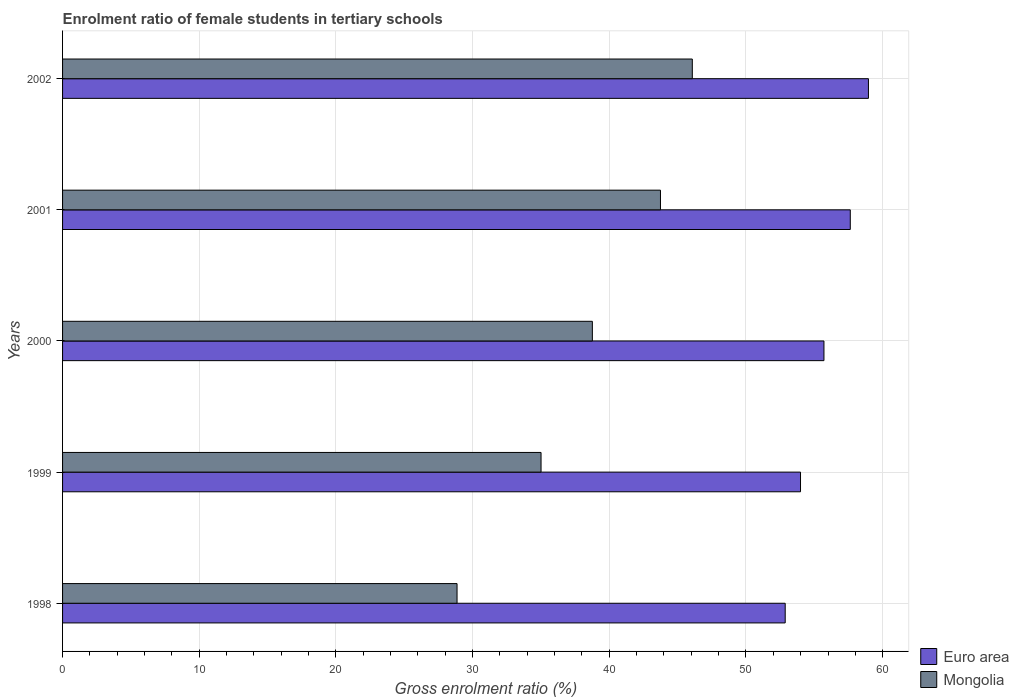In how many cases, is the number of bars for a given year not equal to the number of legend labels?
Provide a succinct answer. 0. What is the enrolment ratio of female students in tertiary schools in Mongolia in 2002?
Give a very brief answer. 46.07. Across all years, what is the maximum enrolment ratio of female students in tertiary schools in Mongolia?
Make the answer very short. 46.07. Across all years, what is the minimum enrolment ratio of female students in tertiary schools in Mongolia?
Keep it short and to the point. 28.86. In which year was the enrolment ratio of female students in tertiary schools in Mongolia minimum?
Keep it short and to the point. 1998. What is the total enrolment ratio of female students in tertiary schools in Euro area in the graph?
Ensure brevity in your answer.  279.15. What is the difference between the enrolment ratio of female students in tertiary schools in Euro area in 1998 and that in 1999?
Offer a terse response. -1.12. What is the difference between the enrolment ratio of female students in tertiary schools in Mongolia in 2001 and the enrolment ratio of female students in tertiary schools in Euro area in 1999?
Make the answer very short. -10.25. What is the average enrolment ratio of female students in tertiary schools in Mongolia per year?
Provide a succinct answer. 38.49. In the year 1999, what is the difference between the enrolment ratio of female students in tertiary schools in Euro area and enrolment ratio of female students in tertiary schools in Mongolia?
Make the answer very short. 18.98. In how many years, is the enrolment ratio of female students in tertiary schools in Euro area greater than 12 %?
Your answer should be compact. 5. What is the ratio of the enrolment ratio of female students in tertiary schools in Mongolia in 1998 to that in 2000?
Offer a terse response. 0.74. Is the enrolment ratio of female students in tertiary schools in Mongolia in 2000 less than that in 2001?
Your answer should be very brief. Yes. What is the difference between the highest and the second highest enrolment ratio of female students in tertiary schools in Mongolia?
Offer a terse response. 2.33. What is the difference between the highest and the lowest enrolment ratio of female students in tertiary schools in Mongolia?
Provide a succinct answer. 17.21. In how many years, is the enrolment ratio of female students in tertiary schools in Euro area greater than the average enrolment ratio of female students in tertiary schools in Euro area taken over all years?
Your answer should be very brief. 2. Is the sum of the enrolment ratio of female students in tertiary schools in Mongolia in 1999 and 2001 greater than the maximum enrolment ratio of female students in tertiary schools in Euro area across all years?
Your answer should be very brief. Yes. What does the 1st bar from the top in 2002 represents?
Your answer should be very brief. Mongolia. What does the 2nd bar from the bottom in 2000 represents?
Your answer should be very brief. Mongolia. How many bars are there?
Offer a very short reply. 10. Are the values on the major ticks of X-axis written in scientific E-notation?
Provide a succinct answer. No. Does the graph contain any zero values?
Your answer should be compact. No. Where does the legend appear in the graph?
Your response must be concise. Bottom right. How many legend labels are there?
Your answer should be very brief. 2. What is the title of the graph?
Your answer should be compact. Enrolment ratio of female students in tertiary schools. What is the Gross enrolment ratio (%) in Euro area in 1998?
Provide a short and direct response. 52.87. What is the Gross enrolment ratio (%) in Mongolia in 1998?
Keep it short and to the point. 28.86. What is the Gross enrolment ratio (%) of Euro area in 1999?
Your answer should be very brief. 53.99. What is the Gross enrolment ratio (%) in Mongolia in 1999?
Your response must be concise. 35.01. What is the Gross enrolment ratio (%) in Euro area in 2000?
Make the answer very short. 55.7. What is the Gross enrolment ratio (%) in Mongolia in 2000?
Provide a succinct answer. 38.76. What is the Gross enrolment ratio (%) of Euro area in 2001?
Your answer should be very brief. 57.63. What is the Gross enrolment ratio (%) of Mongolia in 2001?
Your response must be concise. 43.74. What is the Gross enrolment ratio (%) of Euro area in 2002?
Provide a succinct answer. 58.96. What is the Gross enrolment ratio (%) in Mongolia in 2002?
Your response must be concise. 46.07. Across all years, what is the maximum Gross enrolment ratio (%) of Euro area?
Your answer should be very brief. 58.96. Across all years, what is the maximum Gross enrolment ratio (%) of Mongolia?
Offer a very short reply. 46.07. Across all years, what is the minimum Gross enrolment ratio (%) in Euro area?
Keep it short and to the point. 52.87. Across all years, what is the minimum Gross enrolment ratio (%) of Mongolia?
Ensure brevity in your answer.  28.86. What is the total Gross enrolment ratio (%) of Euro area in the graph?
Make the answer very short. 279.15. What is the total Gross enrolment ratio (%) of Mongolia in the graph?
Your answer should be very brief. 192.45. What is the difference between the Gross enrolment ratio (%) of Euro area in 1998 and that in 1999?
Give a very brief answer. -1.12. What is the difference between the Gross enrolment ratio (%) in Mongolia in 1998 and that in 1999?
Offer a very short reply. -6.15. What is the difference between the Gross enrolment ratio (%) of Euro area in 1998 and that in 2000?
Provide a short and direct response. -2.83. What is the difference between the Gross enrolment ratio (%) in Mongolia in 1998 and that in 2000?
Ensure brevity in your answer.  -9.9. What is the difference between the Gross enrolment ratio (%) in Euro area in 1998 and that in 2001?
Your answer should be very brief. -4.76. What is the difference between the Gross enrolment ratio (%) of Mongolia in 1998 and that in 2001?
Your response must be concise. -14.88. What is the difference between the Gross enrolment ratio (%) in Euro area in 1998 and that in 2002?
Ensure brevity in your answer.  -6.09. What is the difference between the Gross enrolment ratio (%) of Mongolia in 1998 and that in 2002?
Ensure brevity in your answer.  -17.21. What is the difference between the Gross enrolment ratio (%) in Euro area in 1999 and that in 2000?
Provide a short and direct response. -1.71. What is the difference between the Gross enrolment ratio (%) of Mongolia in 1999 and that in 2000?
Your answer should be compact. -3.75. What is the difference between the Gross enrolment ratio (%) of Euro area in 1999 and that in 2001?
Offer a terse response. -3.64. What is the difference between the Gross enrolment ratio (%) of Mongolia in 1999 and that in 2001?
Offer a terse response. -8.74. What is the difference between the Gross enrolment ratio (%) in Euro area in 1999 and that in 2002?
Offer a very short reply. -4.97. What is the difference between the Gross enrolment ratio (%) in Mongolia in 1999 and that in 2002?
Make the answer very short. -11.07. What is the difference between the Gross enrolment ratio (%) of Euro area in 2000 and that in 2001?
Provide a short and direct response. -1.93. What is the difference between the Gross enrolment ratio (%) of Mongolia in 2000 and that in 2001?
Offer a very short reply. -4.98. What is the difference between the Gross enrolment ratio (%) of Euro area in 2000 and that in 2002?
Offer a very short reply. -3.25. What is the difference between the Gross enrolment ratio (%) of Mongolia in 2000 and that in 2002?
Your response must be concise. -7.31. What is the difference between the Gross enrolment ratio (%) in Euro area in 2001 and that in 2002?
Make the answer very short. -1.33. What is the difference between the Gross enrolment ratio (%) in Mongolia in 2001 and that in 2002?
Give a very brief answer. -2.33. What is the difference between the Gross enrolment ratio (%) of Euro area in 1998 and the Gross enrolment ratio (%) of Mongolia in 1999?
Offer a very short reply. 17.86. What is the difference between the Gross enrolment ratio (%) of Euro area in 1998 and the Gross enrolment ratio (%) of Mongolia in 2000?
Your response must be concise. 14.11. What is the difference between the Gross enrolment ratio (%) of Euro area in 1998 and the Gross enrolment ratio (%) of Mongolia in 2001?
Your answer should be very brief. 9.13. What is the difference between the Gross enrolment ratio (%) of Euro area in 1998 and the Gross enrolment ratio (%) of Mongolia in 2002?
Your answer should be very brief. 6.8. What is the difference between the Gross enrolment ratio (%) in Euro area in 1999 and the Gross enrolment ratio (%) in Mongolia in 2000?
Offer a very short reply. 15.23. What is the difference between the Gross enrolment ratio (%) in Euro area in 1999 and the Gross enrolment ratio (%) in Mongolia in 2001?
Offer a very short reply. 10.25. What is the difference between the Gross enrolment ratio (%) in Euro area in 1999 and the Gross enrolment ratio (%) in Mongolia in 2002?
Your response must be concise. 7.92. What is the difference between the Gross enrolment ratio (%) of Euro area in 2000 and the Gross enrolment ratio (%) of Mongolia in 2001?
Offer a terse response. 11.96. What is the difference between the Gross enrolment ratio (%) of Euro area in 2000 and the Gross enrolment ratio (%) of Mongolia in 2002?
Your answer should be compact. 9.63. What is the difference between the Gross enrolment ratio (%) of Euro area in 2001 and the Gross enrolment ratio (%) of Mongolia in 2002?
Provide a short and direct response. 11.56. What is the average Gross enrolment ratio (%) of Euro area per year?
Your answer should be compact. 55.83. What is the average Gross enrolment ratio (%) in Mongolia per year?
Offer a terse response. 38.49. In the year 1998, what is the difference between the Gross enrolment ratio (%) in Euro area and Gross enrolment ratio (%) in Mongolia?
Make the answer very short. 24.01. In the year 1999, what is the difference between the Gross enrolment ratio (%) of Euro area and Gross enrolment ratio (%) of Mongolia?
Your response must be concise. 18.98. In the year 2000, what is the difference between the Gross enrolment ratio (%) in Euro area and Gross enrolment ratio (%) in Mongolia?
Your response must be concise. 16.94. In the year 2001, what is the difference between the Gross enrolment ratio (%) of Euro area and Gross enrolment ratio (%) of Mongolia?
Provide a short and direct response. 13.89. In the year 2002, what is the difference between the Gross enrolment ratio (%) in Euro area and Gross enrolment ratio (%) in Mongolia?
Your answer should be compact. 12.89. What is the ratio of the Gross enrolment ratio (%) of Euro area in 1998 to that in 1999?
Provide a succinct answer. 0.98. What is the ratio of the Gross enrolment ratio (%) in Mongolia in 1998 to that in 1999?
Your answer should be very brief. 0.82. What is the ratio of the Gross enrolment ratio (%) of Euro area in 1998 to that in 2000?
Provide a succinct answer. 0.95. What is the ratio of the Gross enrolment ratio (%) of Mongolia in 1998 to that in 2000?
Your answer should be very brief. 0.74. What is the ratio of the Gross enrolment ratio (%) in Euro area in 1998 to that in 2001?
Give a very brief answer. 0.92. What is the ratio of the Gross enrolment ratio (%) of Mongolia in 1998 to that in 2001?
Give a very brief answer. 0.66. What is the ratio of the Gross enrolment ratio (%) in Euro area in 1998 to that in 2002?
Give a very brief answer. 0.9. What is the ratio of the Gross enrolment ratio (%) in Mongolia in 1998 to that in 2002?
Your answer should be compact. 0.63. What is the ratio of the Gross enrolment ratio (%) of Euro area in 1999 to that in 2000?
Your answer should be very brief. 0.97. What is the ratio of the Gross enrolment ratio (%) of Mongolia in 1999 to that in 2000?
Your response must be concise. 0.9. What is the ratio of the Gross enrolment ratio (%) of Euro area in 1999 to that in 2001?
Keep it short and to the point. 0.94. What is the ratio of the Gross enrolment ratio (%) in Mongolia in 1999 to that in 2001?
Provide a succinct answer. 0.8. What is the ratio of the Gross enrolment ratio (%) in Euro area in 1999 to that in 2002?
Provide a succinct answer. 0.92. What is the ratio of the Gross enrolment ratio (%) in Mongolia in 1999 to that in 2002?
Provide a short and direct response. 0.76. What is the ratio of the Gross enrolment ratio (%) of Euro area in 2000 to that in 2001?
Offer a terse response. 0.97. What is the ratio of the Gross enrolment ratio (%) in Mongolia in 2000 to that in 2001?
Your answer should be very brief. 0.89. What is the ratio of the Gross enrolment ratio (%) in Euro area in 2000 to that in 2002?
Offer a very short reply. 0.94. What is the ratio of the Gross enrolment ratio (%) of Mongolia in 2000 to that in 2002?
Provide a succinct answer. 0.84. What is the ratio of the Gross enrolment ratio (%) of Euro area in 2001 to that in 2002?
Offer a very short reply. 0.98. What is the ratio of the Gross enrolment ratio (%) in Mongolia in 2001 to that in 2002?
Your answer should be very brief. 0.95. What is the difference between the highest and the second highest Gross enrolment ratio (%) of Euro area?
Provide a short and direct response. 1.33. What is the difference between the highest and the second highest Gross enrolment ratio (%) in Mongolia?
Ensure brevity in your answer.  2.33. What is the difference between the highest and the lowest Gross enrolment ratio (%) of Euro area?
Offer a very short reply. 6.09. What is the difference between the highest and the lowest Gross enrolment ratio (%) of Mongolia?
Your answer should be very brief. 17.21. 